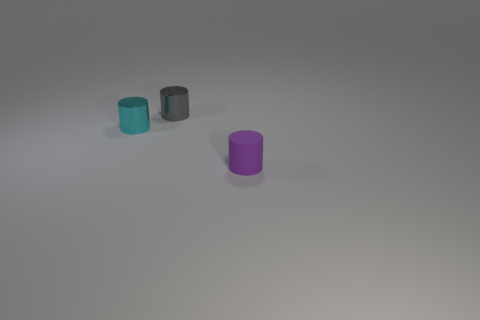Is the tiny cylinder that is behind the cyan metallic cylinder made of the same material as the small cylinder that is right of the small gray metal object?
Ensure brevity in your answer.  No. Are there an equal number of tiny purple things to the right of the small gray cylinder and purple objects behind the matte object?
Offer a terse response. No. What number of cylinders have the same color as the tiny rubber thing?
Your response must be concise. 0. How many rubber objects are small blue cylinders or small cyan cylinders?
Keep it short and to the point. 0. There is a cyan shiny cylinder; what number of tiny cylinders are in front of it?
Ensure brevity in your answer.  1. Are there any cyan cylinders that have the same material as the tiny purple cylinder?
Make the answer very short. No. There is a purple thing that is the same size as the gray object; what is it made of?
Your answer should be compact. Rubber. Does the purple object have the same material as the gray thing?
Ensure brevity in your answer.  No. How many objects are shiny cylinders or cylinders?
Your answer should be very brief. 3. What is the shape of the metallic object that is to the right of the cyan shiny cylinder?
Your response must be concise. Cylinder. 